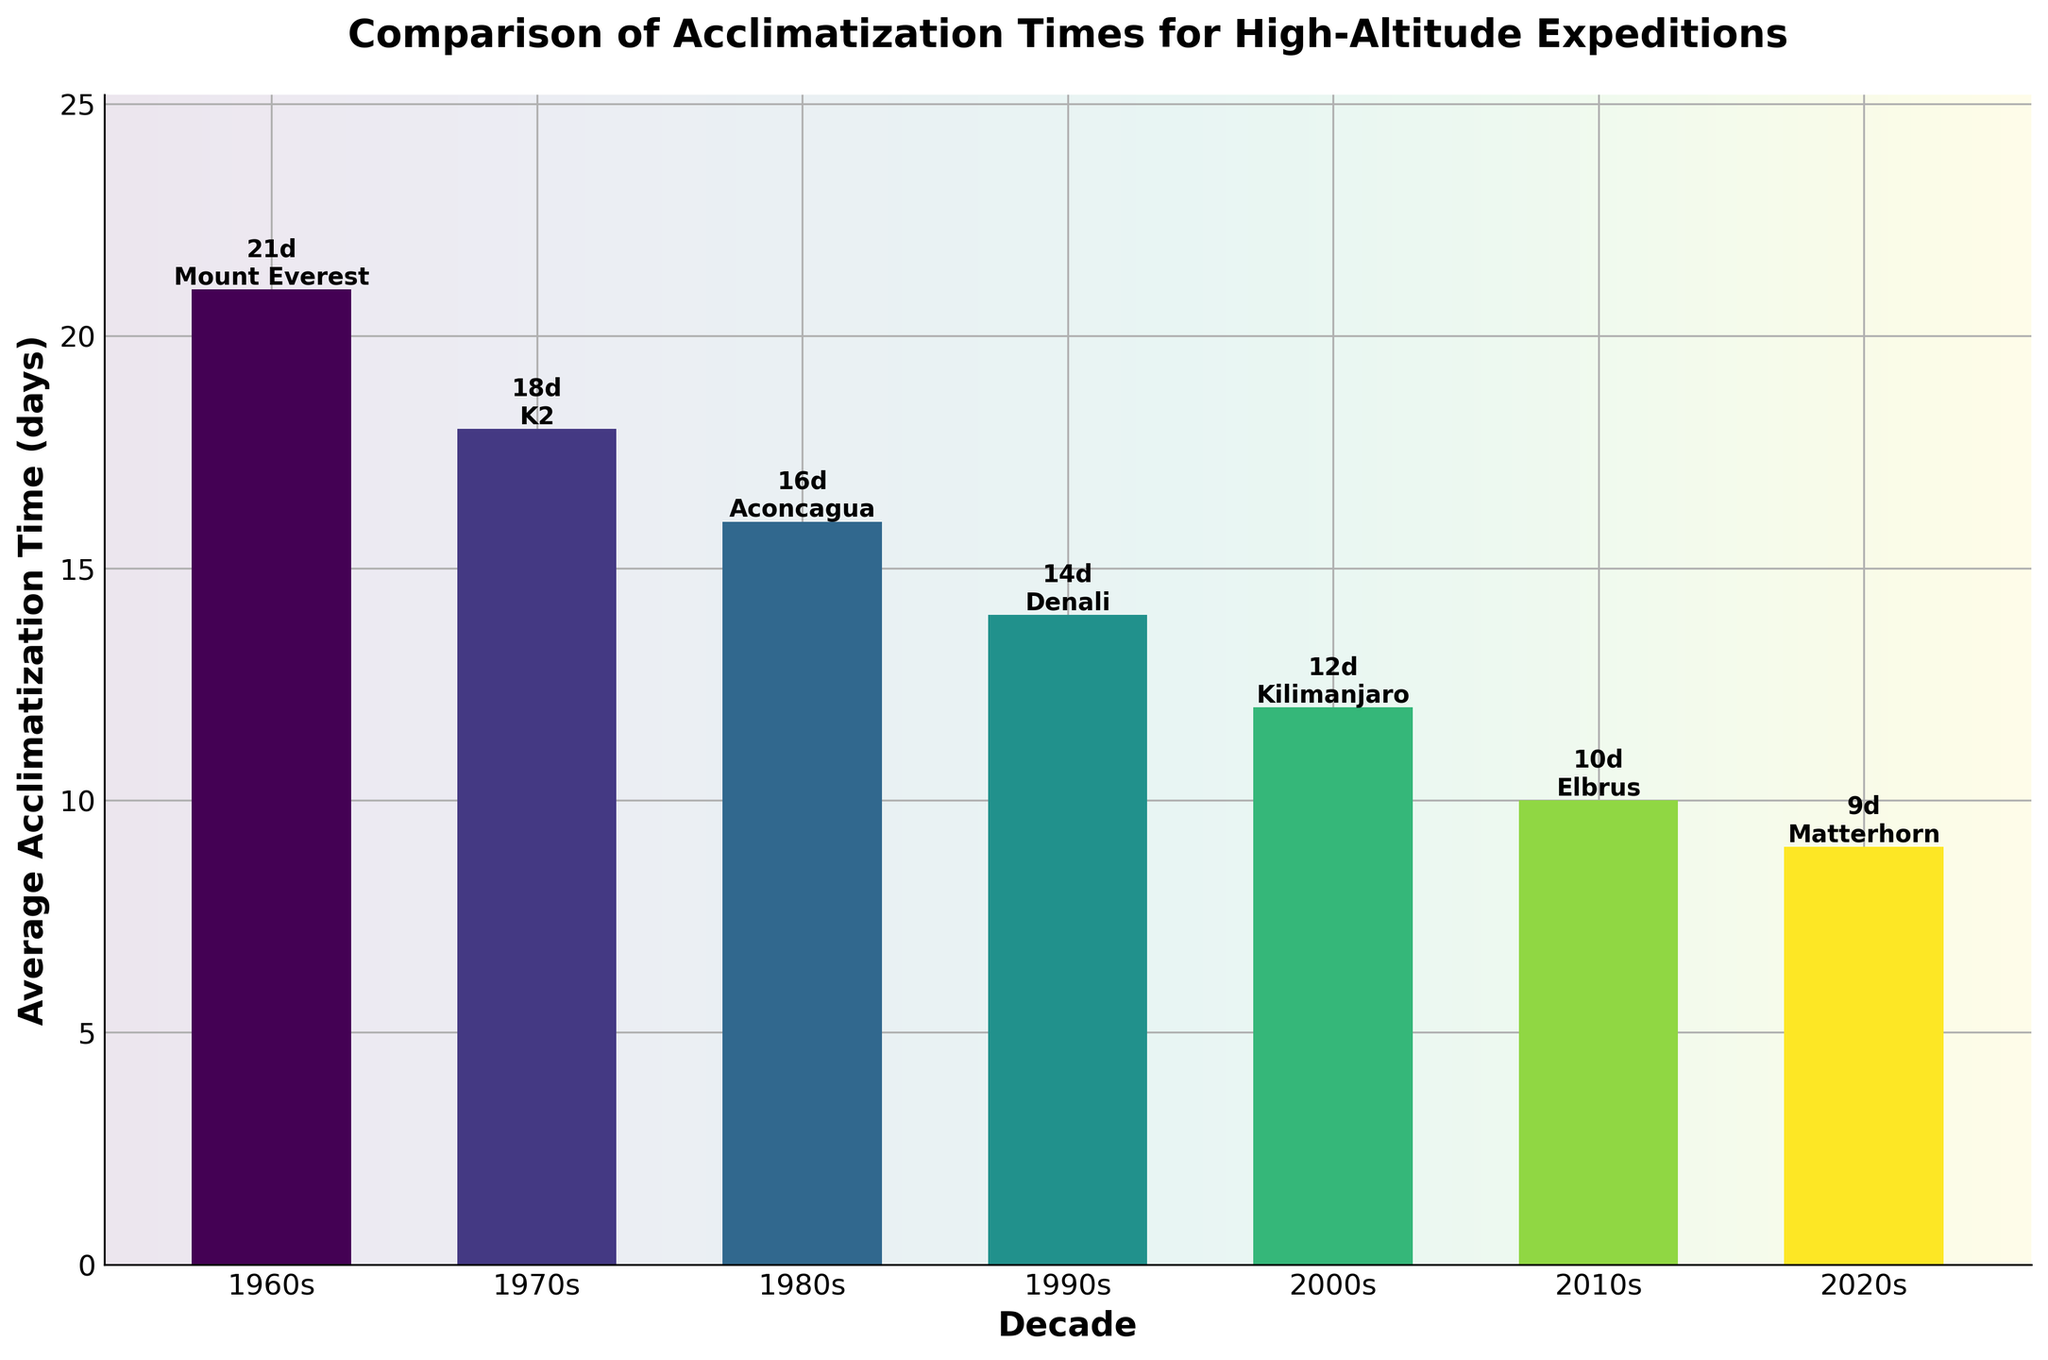What decade had the longest average acclimatization time? The bar representing the 1960s is the tallest, indicating the longest average acclimatization time.
Answer: 1960s What is the difference in average acclimatization time between the 1960s and 2020s? The height of the bar for the 1960s represents 21 days and the bar for the 2020s represents 9 days. Subtract 9 from 21.
Answer: 12 days Which expedition location required the least average acclimatization time? The bar labeled with the shortest height corresponds to the 2020s, and the text above it indicates the location as Matterhorn.
Answer: Matterhorn How has the average acclimatization time changed from the 1990s to the 2010s? The bar for the 1990s is 14 days and for the 2010s is 10 days, indicating a reduction. Subtract 10 from 14.
Answer: Decreased by 4 days Which decade saw the greatest reduction in average acclimatization time compared to the previous decade? Calculate the difference for each pair of consecutive decades: 
1960s to 1970s: 21-18=3 
1970s to 1980s: 18-16=2 
1980s to 1990s: 16-14=2 
1990s to 2000s: 14-12=2 
2000s to 2010s: 12-10=2 
2010s to 2020s: 10-9=1 
The largest reduction is 3 days between the 1960s and 1970s.
Answer: 1960s to 1970s What is the combined average acclimatization time of the 1980s and 2000s? The heights of the bars for the 1980s and 2000s are 16 days and 12 days; add them together.
Answer: 28 days Which expedition location appears in the 2000s and what is its average acclimatization time? The label above the bar for the 2000s shows the expedition location as Kilimanjaro and the bar height is 12 days.
Answer: Kilimanjaro, 12 days What is the average acclimatization time across all decades shown in the bar chart? Average is calculated by summing all values and dividing by the number of values. (21+18+16+14+12+10+9)/7 = 100/7
Answer: Approximately 14.29 days Compare the visual difference between the bars representing the 1970s and 1990s. The bar for the 1970s is taller than that for the 1990s. Specifically, the bar for the 1970s is 18 days while the 1990s is 14 days.
Answer: 1970s is taller by 4 days Which decade saw the smallest change in average acclimatization time compared to its preceding decade? Compare the differences between each consecutive decade: 
1960s to 1970s: 21-18=3 
1970s to 1980s: 18-16=2 
1980s to 1990s: 16-14=2 
1990s to 2000s: 14-12=2 
2000s to 2010s: 12-10=2 
2010s to 2020s: 10-9=1 
The 2010s to 2020s period saw a change of only 1 day.
Answer: 2010s to 2020s 